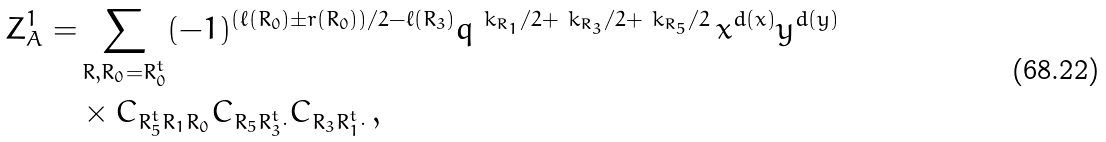<formula> <loc_0><loc_0><loc_500><loc_500>Z _ { A } ^ { 1 } = & \sum _ { R , R _ { 0 } = R _ { 0 } ^ { t } } ( - 1 ) ^ { ( \ell ( R _ { 0 } ) \pm r ( R _ { 0 } ) ) / 2 - \ell ( R _ { 3 } ) } q ^ { \ k _ { R _ { 1 } } / 2 + \ k _ { R _ { 3 } } / 2 + \ k _ { R _ { 5 } } / 2 } \, x ^ { d ( x ) } y ^ { d ( y ) } \\ & \times C _ { R _ { 5 } ^ { t } R _ { 1 } R _ { 0 } } C _ { R _ { 5 } R _ { 3 } ^ { t } \cdot } C _ { R _ { 3 } R _ { 1 } ^ { t } \cdot } \, ,</formula> 